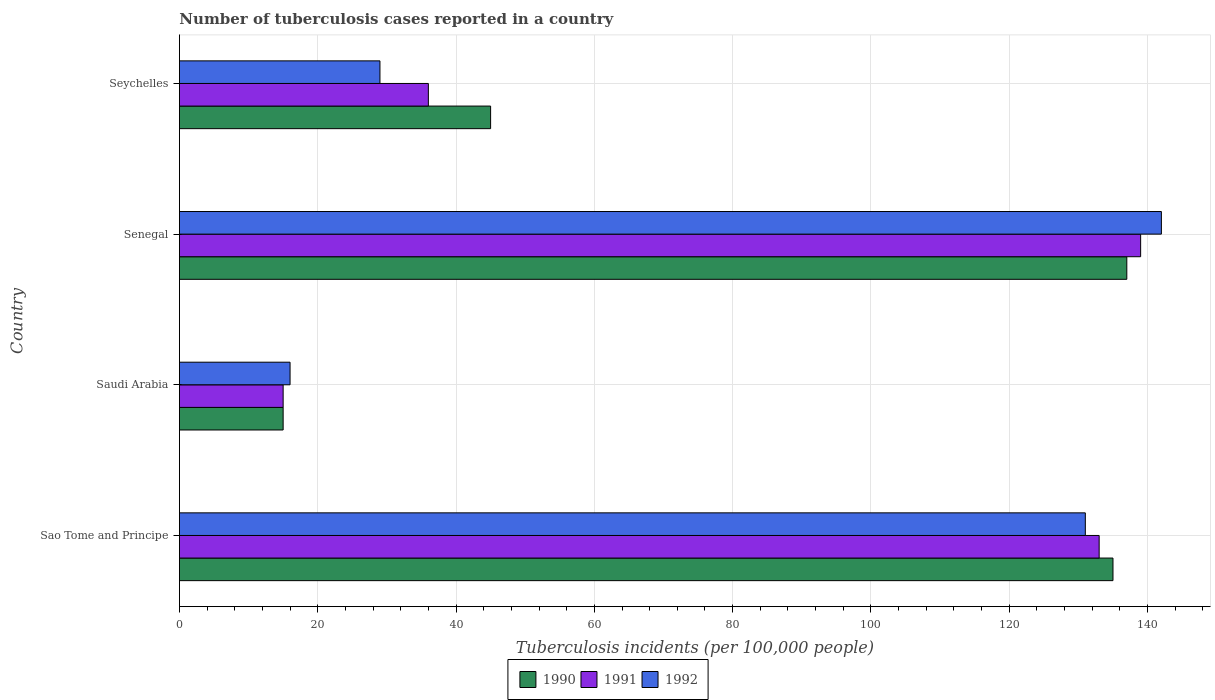How many groups of bars are there?
Your answer should be compact. 4. Are the number of bars per tick equal to the number of legend labels?
Your answer should be very brief. Yes. How many bars are there on the 1st tick from the top?
Provide a succinct answer. 3. How many bars are there on the 1st tick from the bottom?
Provide a succinct answer. 3. What is the label of the 4th group of bars from the top?
Make the answer very short. Sao Tome and Principe. Across all countries, what is the maximum number of tuberculosis cases reported in in 1992?
Make the answer very short. 142. In which country was the number of tuberculosis cases reported in in 1992 maximum?
Your response must be concise. Senegal. In which country was the number of tuberculosis cases reported in in 1992 minimum?
Keep it short and to the point. Saudi Arabia. What is the total number of tuberculosis cases reported in in 1990 in the graph?
Offer a very short reply. 332. What is the difference between the number of tuberculosis cases reported in in 1991 in Saudi Arabia and the number of tuberculosis cases reported in in 1992 in Sao Tome and Principe?
Ensure brevity in your answer.  -116. What is the average number of tuberculosis cases reported in in 1992 per country?
Offer a very short reply. 79.5. In how many countries, is the number of tuberculosis cases reported in in 1991 greater than 16 ?
Your answer should be compact. 3. Is the number of tuberculosis cases reported in in 1992 in Senegal less than that in Seychelles?
Offer a very short reply. No. What is the difference between the highest and the second highest number of tuberculosis cases reported in in 1991?
Provide a short and direct response. 6. What is the difference between the highest and the lowest number of tuberculosis cases reported in in 1992?
Your answer should be very brief. 126. In how many countries, is the number of tuberculosis cases reported in in 1992 greater than the average number of tuberculosis cases reported in in 1992 taken over all countries?
Give a very brief answer. 2. What does the 2nd bar from the top in Senegal represents?
Make the answer very short. 1991. What does the 1st bar from the bottom in Seychelles represents?
Offer a very short reply. 1990. Is it the case that in every country, the sum of the number of tuberculosis cases reported in in 1992 and number of tuberculosis cases reported in in 1990 is greater than the number of tuberculosis cases reported in in 1991?
Ensure brevity in your answer.  Yes. How many bars are there?
Make the answer very short. 12. What is the difference between two consecutive major ticks on the X-axis?
Ensure brevity in your answer.  20. How many legend labels are there?
Your answer should be very brief. 3. How are the legend labels stacked?
Offer a terse response. Horizontal. What is the title of the graph?
Offer a terse response. Number of tuberculosis cases reported in a country. What is the label or title of the X-axis?
Offer a very short reply. Tuberculosis incidents (per 100,0 people). What is the Tuberculosis incidents (per 100,000 people) in 1990 in Sao Tome and Principe?
Offer a terse response. 135. What is the Tuberculosis incidents (per 100,000 people) of 1991 in Sao Tome and Principe?
Your answer should be very brief. 133. What is the Tuberculosis incidents (per 100,000 people) in 1992 in Sao Tome and Principe?
Make the answer very short. 131. What is the Tuberculosis incidents (per 100,000 people) in 1991 in Saudi Arabia?
Provide a short and direct response. 15. What is the Tuberculosis incidents (per 100,000 people) of 1990 in Senegal?
Provide a short and direct response. 137. What is the Tuberculosis incidents (per 100,000 people) of 1991 in Senegal?
Make the answer very short. 139. What is the Tuberculosis incidents (per 100,000 people) in 1992 in Senegal?
Provide a succinct answer. 142. What is the Tuberculosis incidents (per 100,000 people) of 1991 in Seychelles?
Give a very brief answer. 36. Across all countries, what is the maximum Tuberculosis incidents (per 100,000 people) of 1990?
Give a very brief answer. 137. Across all countries, what is the maximum Tuberculosis incidents (per 100,000 people) in 1991?
Your answer should be compact. 139. Across all countries, what is the maximum Tuberculosis incidents (per 100,000 people) in 1992?
Offer a terse response. 142. Across all countries, what is the minimum Tuberculosis incidents (per 100,000 people) in 1990?
Provide a short and direct response. 15. Across all countries, what is the minimum Tuberculosis incidents (per 100,000 people) of 1991?
Offer a very short reply. 15. Across all countries, what is the minimum Tuberculosis incidents (per 100,000 people) in 1992?
Ensure brevity in your answer.  16. What is the total Tuberculosis incidents (per 100,000 people) in 1990 in the graph?
Keep it short and to the point. 332. What is the total Tuberculosis incidents (per 100,000 people) of 1991 in the graph?
Make the answer very short. 323. What is the total Tuberculosis incidents (per 100,000 people) of 1992 in the graph?
Ensure brevity in your answer.  318. What is the difference between the Tuberculosis incidents (per 100,000 people) of 1990 in Sao Tome and Principe and that in Saudi Arabia?
Provide a short and direct response. 120. What is the difference between the Tuberculosis incidents (per 100,000 people) of 1991 in Sao Tome and Principe and that in Saudi Arabia?
Your answer should be very brief. 118. What is the difference between the Tuberculosis incidents (per 100,000 people) in 1992 in Sao Tome and Principe and that in Saudi Arabia?
Your response must be concise. 115. What is the difference between the Tuberculosis incidents (per 100,000 people) of 1990 in Sao Tome and Principe and that in Senegal?
Make the answer very short. -2. What is the difference between the Tuberculosis incidents (per 100,000 people) in 1991 in Sao Tome and Principe and that in Senegal?
Make the answer very short. -6. What is the difference between the Tuberculosis incidents (per 100,000 people) in 1992 in Sao Tome and Principe and that in Senegal?
Keep it short and to the point. -11. What is the difference between the Tuberculosis incidents (per 100,000 people) of 1991 in Sao Tome and Principe and that in Seychelles?
Offer a terse response. 97. What is the difference between the Tuberculosis incidents (per 100,000 people) in 1992 in Sao Tome and Principe and that in Seychelles?
Your response must be concise. 102. What is the difference between the Tuberculosis incidents (per 100,000 people) in 1990 in Saudi Arabia and that in Senegal?
Provide a short and direct response. -122. What is the difference between the Tuberculosis incidents (per 100,000 people) of 1991 in Saudi Arabia and that in Senegal?
Give a very brief answer. -124. What is the difference between the Tuberculosis incidents (per 100,000 people) of 1992 in Saudi Arabia and that in Senegal?
Make the answer very short. -126. What is the difference between the Tuberculosis incidents (per 100,000 people) of 1991 in Saudi Arabia and that in Seychelles?
Keep it short and to the point. -21. What is the difference between the Tuberculosis incidents (per 100,000 people) in 1990 in Senegal and that in Seychelles?
Your answer should be very brief. 92. What is the difference between the Tuberculosis incidents (per 100,000 people) in 1991 in Senegal and that in Seychelles?
Your answer should be very brief. 103. What is the difference between the Tuberculosis incidents (per 100,000 people) of 1992 in Senegal and that in Seychelles?
Your answer should be very brief. 113. What is the difference between the Tuberculosis incidents (per 100,000 people) in 1990 in Sao Tome and Principe and the Tuberculosis incidents (per 100,000 people) in 1991 in Saudi Arabia?
Your answer should be very brief. 120. What is the difference between the Tuberculosis incidents (per 100,000 people) in 1990 in Sao Tome and Principe and the Tuberculosis incidents (per 100,000 people) in 1992 in Saudi Arabia?
Offer a very short reply. 119. What is the difference between the Tuberculosis incidents (per 100,000 people) in 1991 in Sao Tome and Principe and the Tuberculosis incidents (per 100,000 people) in 1992 in Saudi Arabia?
Your response must be concise. 117. What is the difference between the Tuberculosis incidents (per 100,000 people) in 1990 in Sao Tome and Principe and the Tuberculosis incidents (per 100,000 people) in 1991 in Senegal?
Your answer should be compact. -4. What is the difference between the Tuberculosis incidents (per 100,000 people) of 1990 in Sao Tome and Principe and the Tuberculosis incidents (per 100,000 people) of 1992 in Senegal?
Ensure brevity in your answer.  -7. What is the difference between the Tuberculosis incidents (per 100,000 people) in 1990 in Sao Tome and Principe and the Tuberculosis incidents (per 100,000 people) in 1992 in Seychelles?
Offer a very short reply. 106. What is the difference between the Tuberculosis incidents (per 100,000 people) of 1991 in Sao Tome and Principe and the Tuberculosis incidents (per 100,000 people) of 1992 in Seychelles?
Provide a succinct answer. 104. What is the difference between the Tuberculosis incidents (per 100,000 people) of 1990 in Saudi Arabia and the Tuberculosis incidents (per 100,000 people) of 1991 in Senegal?
Give a very brief answer. -124. What is the difference between the Tuberculosis incidents (per 100,000 people) of 1990 in Saudi Arabia and the Tuberculosis incidents (per 100,000 people) of 1992 in Senegal?
Give a very brief answer. -127. What is the difference between the Tuberculosis incidents (per 100,000 people) in 1991 in Saudi Arabia and the Tuberculosis incidents (per 100,000 people) in 1992 in Senegal?
Offer a very short reply. -127. What is the difference between the Tuberculosis incidents (per 100,000 people) of 1990 in Saudi Arabia and the Tuberculosis incidents (per 100,000 people) of 1991 in Seychelles?
Your response must be concise. -21. What is the difference between the Tuberculosis incidents (per 100,000 people) in 1990 in Saudi Arabia and the Tuberculosis incidents (per 100,000 people) in 1992 in Seychelles?
Offer a terse response. -14. What is the difference between the Tuberculosis incidents (per 100,000 people) of 1990 in Senegal and the Tuberculosis incidents (per 100,000 people) of 1991 in Seychelles?
Give a very brief answer. 101. What is the difference between the Tuberculosis incidents (per 100,000 people) of 1990 in Senegal and the Tuberculosis incidents (per 100,000 people) of 1992 in Seychelles?
Your response must be concise. 108. What is the difference between the Tuberculosis incidents (per 100,000 people) in 1991 in Senegal and the Tuberculosis incidents (per 100,000 people) in 1992 in Seychelles?
Keep it short and to the point. 110. What is the average Tuberculosis incidents (per 100,000 people) of 1991 per country?
Provide a short and direct response. 80.75. What is the average Tuberculosis incidents (per 100,000 people) in 1992 per country?
Your response must be concise. 79.5. What is the difference between the Tuberculosis incidents (per 100,000 people) of 1990 and Tuberculosis incidents (per 100,000 people) of 1991 in Sao Tome and Principe?
Ensure brevity in your answer.  2. What is the difference between the Tuberculosis incidents (per 100,000 people) of 1991 and Tuberculosis incidents (per 100,000 people) of 1992 in Sao Tome and Principe?
Your response must be concise. 2. What is the difference between the Tuberculosis incidents (per 100,000 people) in 1990 and Tuberculosis incidents (per 100,000 people) in 1991 in Saudi Arabia?
Keep it short and to the point. 0. What is the difference between the Tuberculosis incidents (per 100,000 people) of 1990 and Tuberculosis incidents (per 100,000 people) of 1992 in Saudi Arabia?
Your answer should be compact. -1. What is the difference between the Tuberculosis incidents (per 100,000 people) in 1990 and Tuberculosis incidents (per 100,000 people) in 1992 in Senegal?
Provide a short and direct response. -5. What is the difference between the Tuberculosis incidents (per 100,000 people) of 1990 and Tuberculosis incidents (per 100,000 people) of 1991 in Seychelles?
Provide a succinct answer. 9. What is the difference between the Tuberculosis incidents (per 100,000 people) in 1990 and Tuberculosis incidents (per 100,000 people) in 1992 in Seychelles?
Offer a terse response. 16. What is the difference between the Tuberculosis incidents (per 100,000 people) in 1991 and Tuberculosis incidents (per 100,000 people) in 1992 in Seychelles?
Your answer should be compact. 7. What is the ratio of the Tuberculosis incidents (per 100,000 people) of 1991 in Sao Tome and Principe to that in Saudi Arabia?
Offer a very short reply. 8.87. What is the ratio of the Tuberculosis incidents (per 100,000 people) in 1992 in Sao Tome and Principe to that in Saudi Arabia?
Provide a succinct answer. 8.19. What is the ratio of the Tuberculosis incidents (per 100,000 people) of 1990 in Sao Tome and Principe to that in Senegal?
Offer a very short reply. 0.99. What is the ratio of the Tuberculosis incidents (per 100,000 people) of 1991 in Sao Tome and Principe to that in Senegal?
Make the answer very short. 0.96. What is the ratio of the Tuberculosis incidents (per 100,000 people) of 1992 in Sao Tome and Principe to that in Senegal?
Provide a short and direct response. 0.92. What is the ratio of the Tuberculosis incidents (per 100,000 people) in 1991 in Sao Tome and Principe to that in Seychelles?
Give a very brief answer. 3.69. What is the ratio of the Tuberculosis incidents (per 100,000 people) in 1992 in Sao Tome and Principe to that in Seychelles?
Your response must be concise. 4.52. What is the ratio of the Tuberculosis incidents (per 100,000 people) of 1990 in Saudi Arabia to that in Senegal?
Offer a terse response. 0.11. What is the ratio of the Tuberculosis incidents (per 100,000 people) of 1991 in Saudi Arabia to that in Senegal?
Keep it short and to the point. 0.11. What is the ratio of the Tuberculosis incidents (per 100,000 people) of 1992 in Saudi Arabia to that in Senegal?
Your response must be concise. 0.11. What is the ratio of the Tuberculosis incidents (per 100,000 people) of 1991 in Saudi Arabia to that in Seychelles?
Ensure brevity in your answer.  0.42. What is the ratio of the Tuberculosis incidents (per 100,000 people) in 1992 in Saudi Arabia to that in Seychelles?
Your answer should be very brief. 0.55. What is the ratio of the Tuberculosis incidents (per 100,000 people) of 1990 in Senegal to that in Seychelles?
Make the answer very short. 3.04. What is the ratio of the Tuberculosis incidents (per 100,000 people) of 1991 in Senegal to that in Seychelles?
Make the answer very short. 3.86. What is the ratio of the Tuberculosis incidents (per 100,000 people) in 1992 in Senegal to that in Seychelles?
Offer a terse response. 4.9. What is the difference between the highest and the second highest Tuberculosis incidents (per 100,000 people) in 1990?
Your answer should be compact. 2. What is the difference between the highest and the second highest Tuberculosis incidents (per 100,000 people) in 1991?
Provide a succinct answer. 6. What is the difference between the highest and the lowest Tuberculosis incidents (per 100,000 people) in 1990?
Keep it short and to the point. 122. What is the difference between the highest and the lowest Tuberculosis incidents (per 100,000 people) of 1991?
Offer a very short reply. 124. What is the difference between the highest and the lowest Tuberculosis incidents (per 100,000 people) in 1992?
Your response must be concise. 126. 